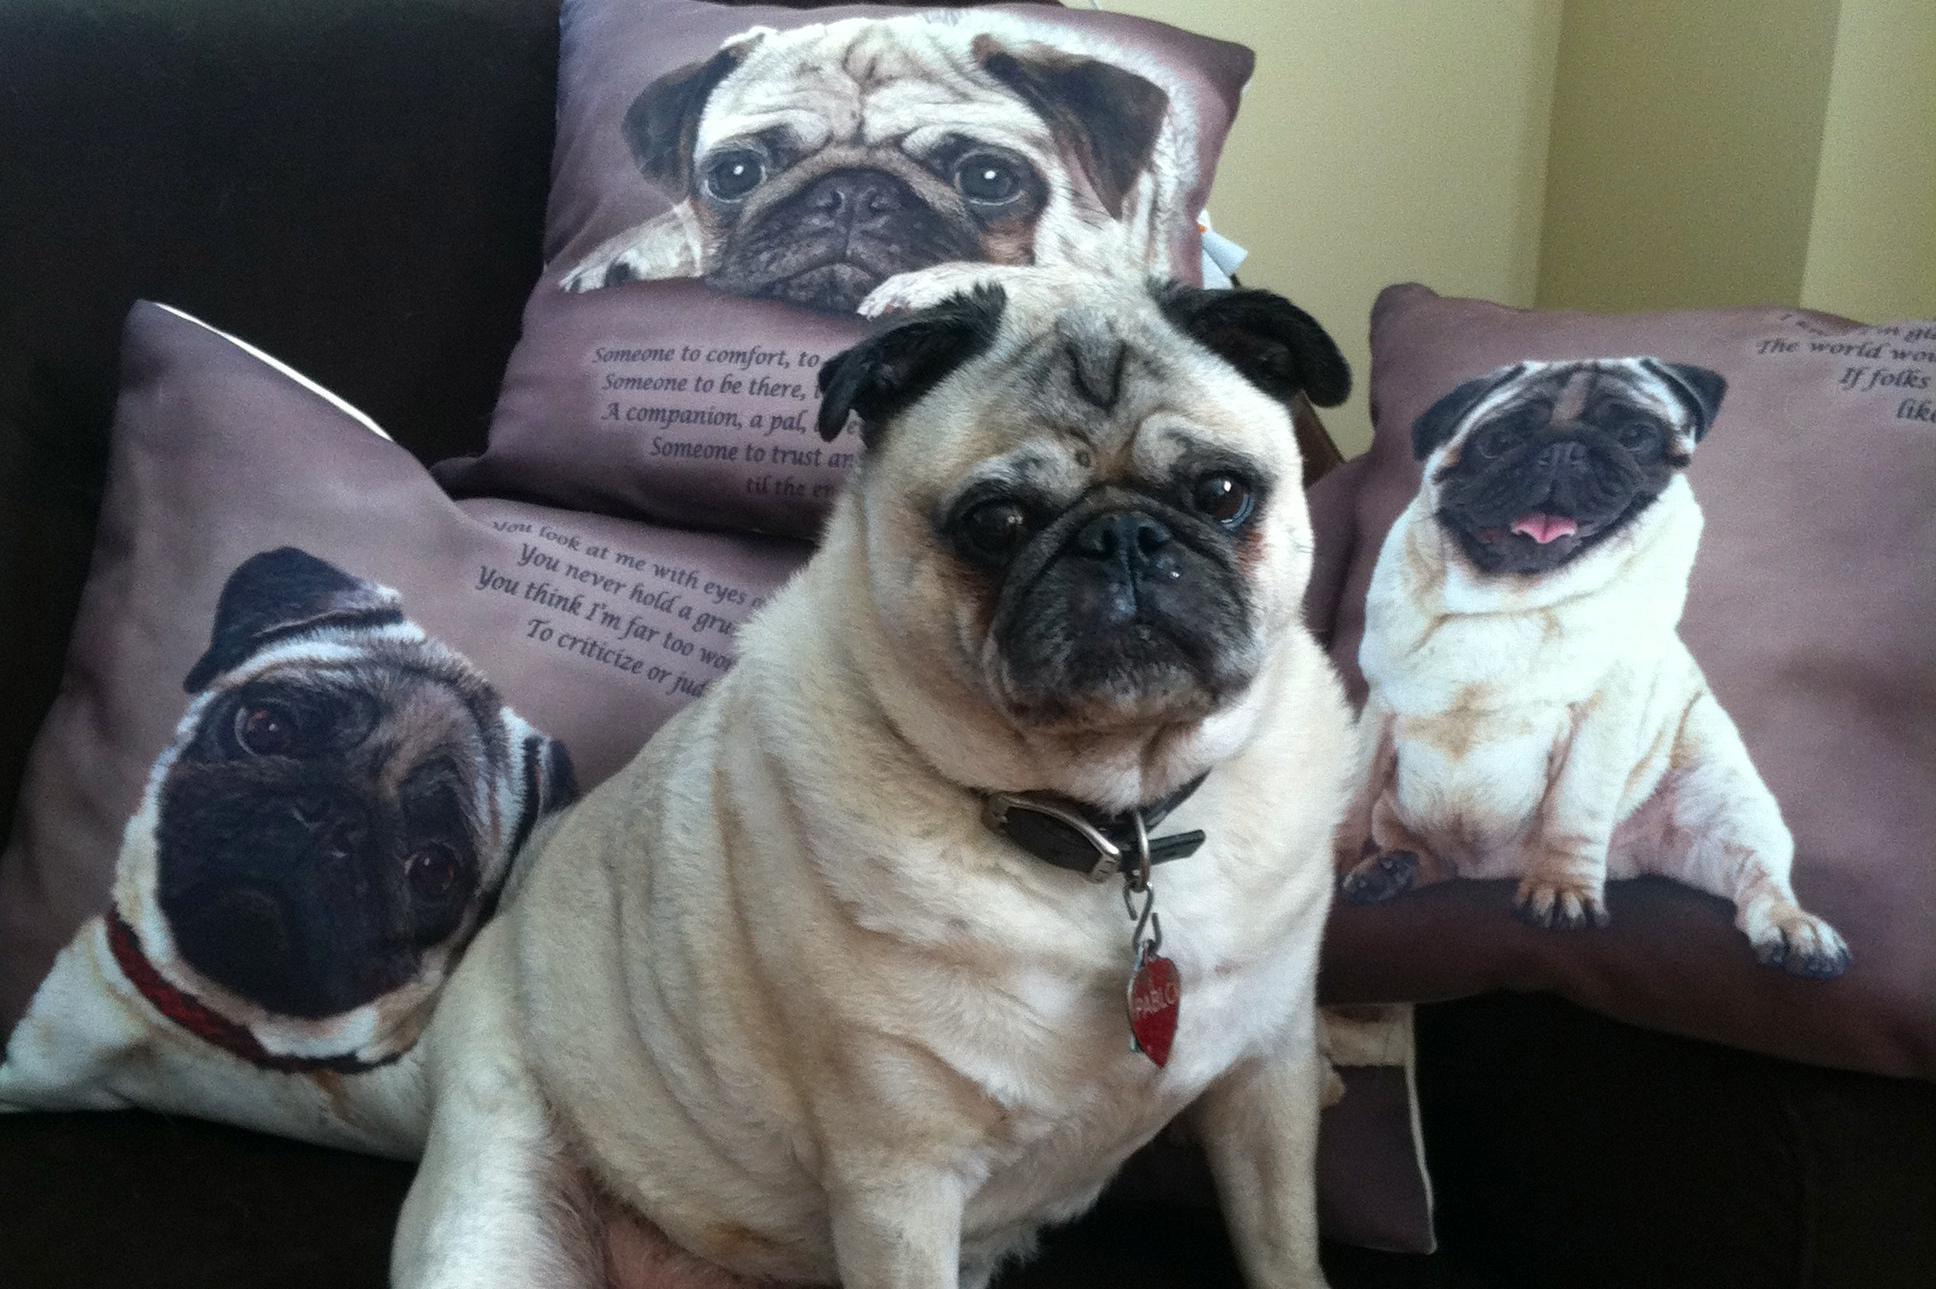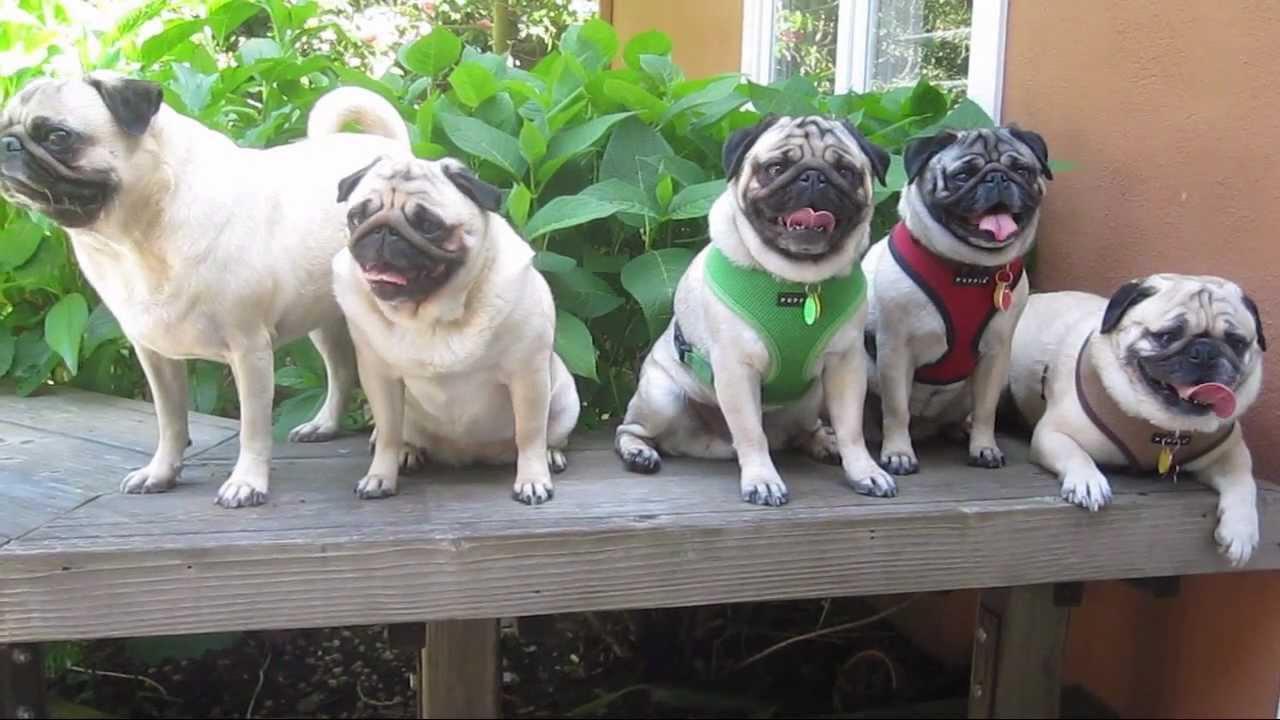The first image is the image on the left, the second image is the image on the right. Given the left and right images, does the statement "There are less than 5 dogs in the left image." hold true? Answer yes or no. Yes. 